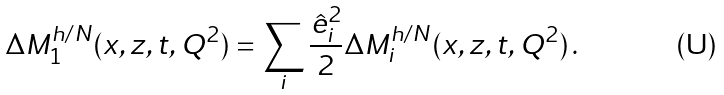<formula> <loc_0><loc_0><loc_500><loc_500>\Delta M _ { 1 } ^ { h / N } ( x , z , t , Q ^ { 2 } ) = \sum _ { i } \frac { \hat { e } _ { i } ^ { 2 } } { 2 } \Delta M _ { i } ^ { h / N } ( x , z , t , Q ^ { 2 } ) \, .</formula> 